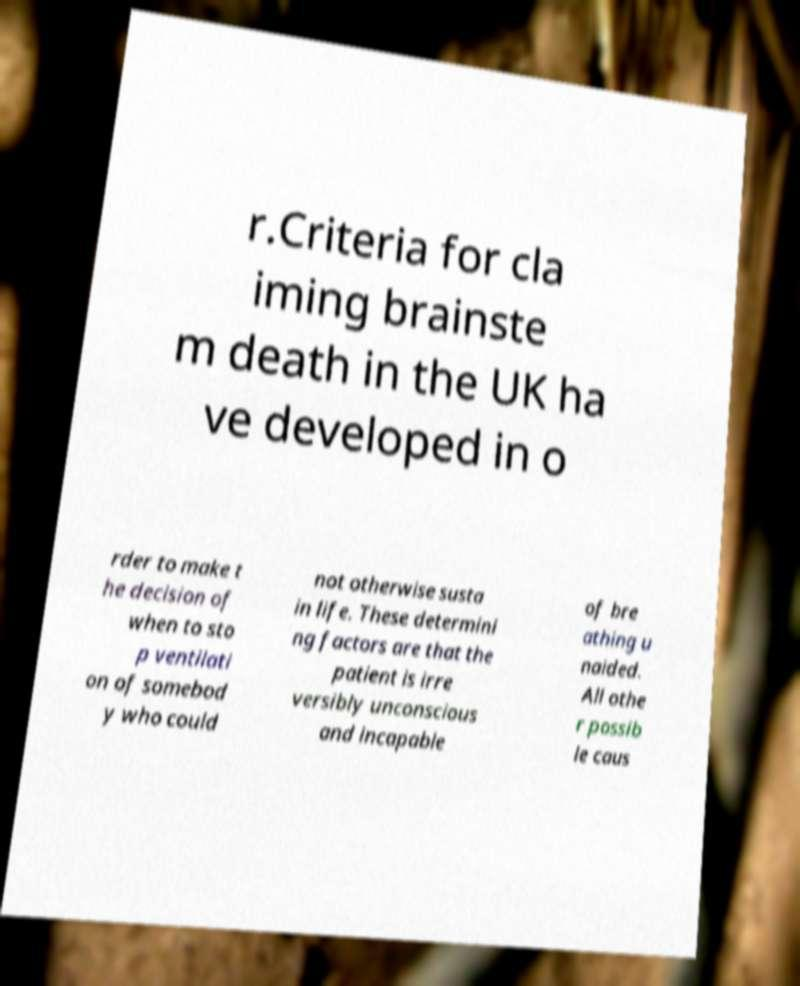Please read and relay the text visible in this image. What does it say? r.Criteria for cla iming brainste m death in the UK ha ve developed in o rder to make t he decision of when to sto p ventilati on of somebod y who could not otherwise susta in life. These determini ng factors are that the patient is irre versibly unconscious and incapable of bre athing u naided. All othe r possib le caus 